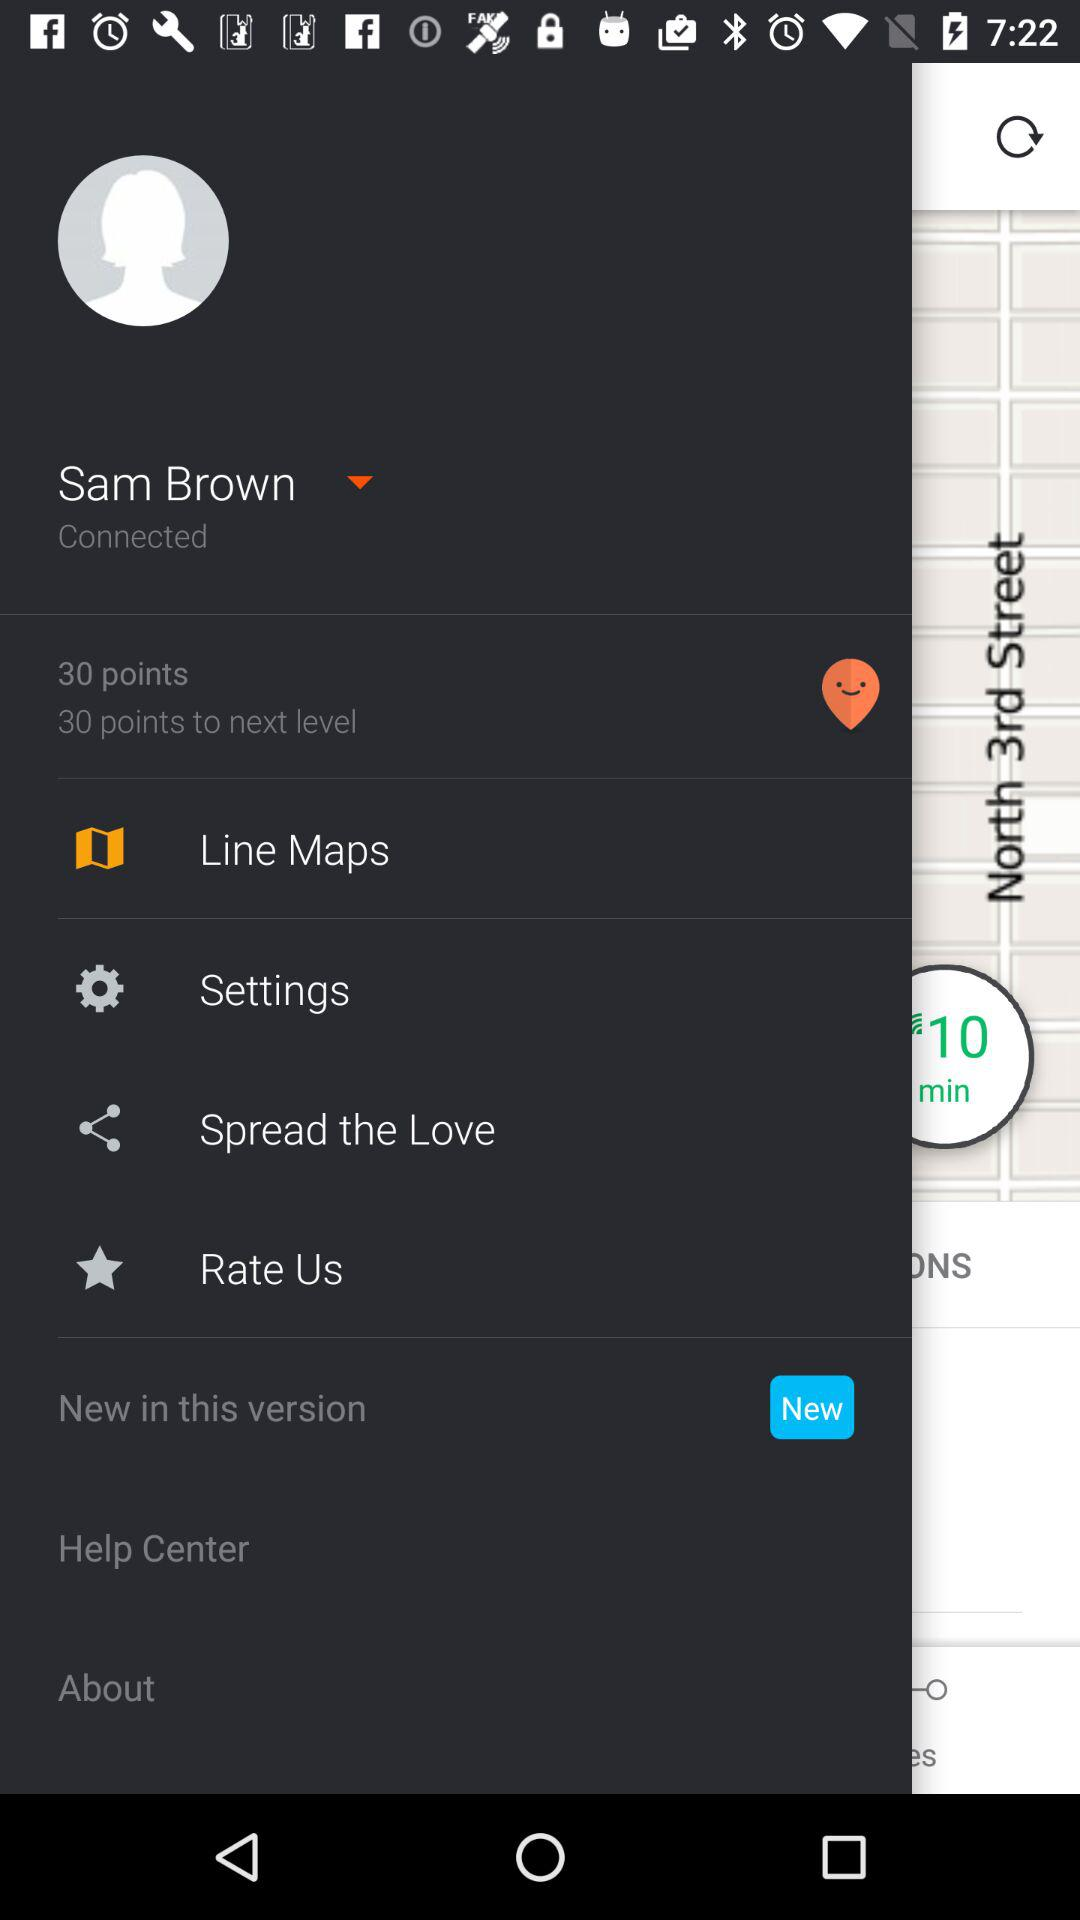How many points are required for the next level? The number of points required for the next level is 30. 